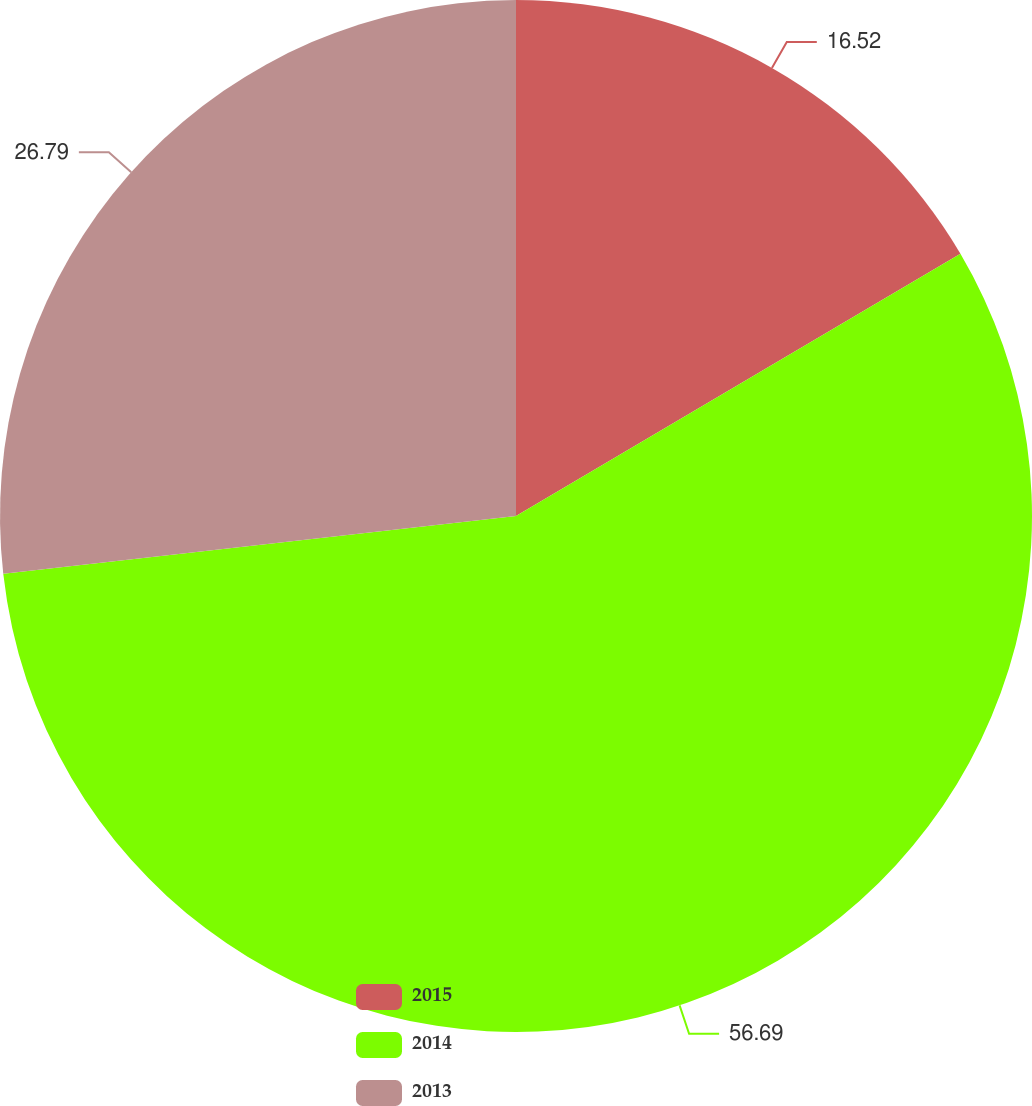Convert chart. <chart><loc_0><loc_0><loc_500><loc_500><pie_chart><fcel>2015<fcel>2014<fcel>2013<nl><fcel>16.52%<fcel>56.7%<fcel>26.79%<nl></chart> 